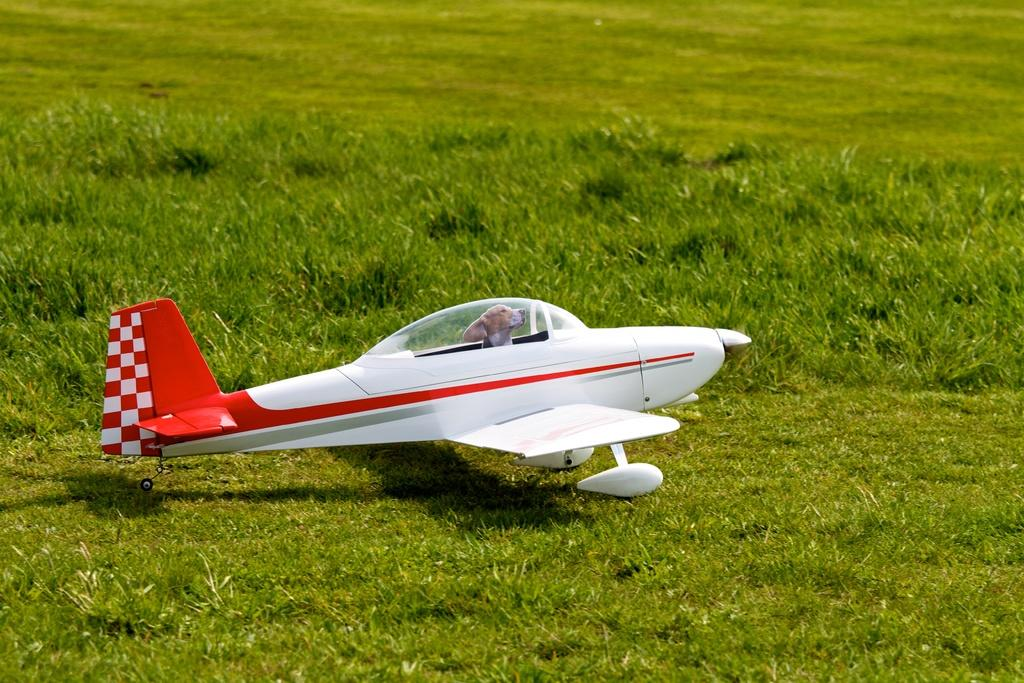What is the main subject of the image? The main subject of the image is an aircraft. Where is the aircraft located? The aircraft is on the grass. Is there anything else inside the aircraft besides the aircraft itself? Yes, there is a dog inside the aircraft. What type of street is visible in the image? There is no street visible in the image; it features an aircraft on the grass with a dog inside. How does the dog use its mouth to interact with the aircraft? There is no indication in the image that the dog is interacting with the aircraft using its mouth. 